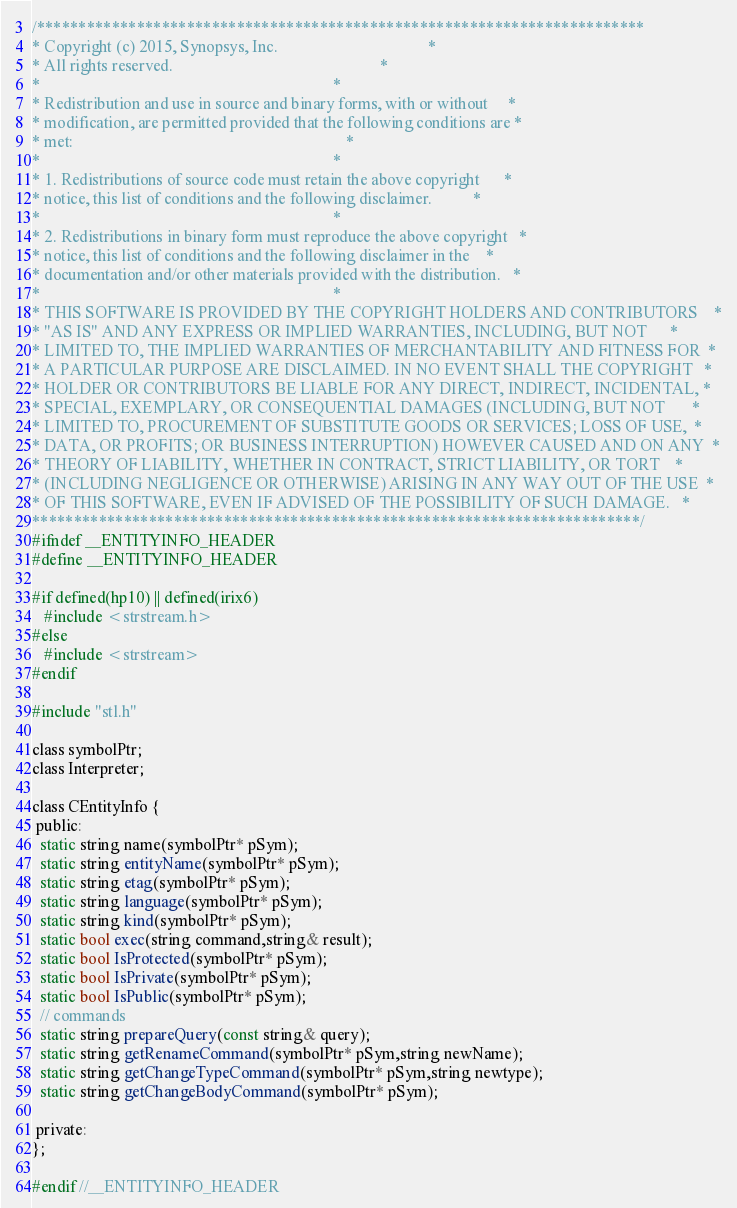Convert code to text. <code><loc_0><loc_0><loc_500><loc_500><_C_>/*************************************************************************
* Copyright (c) 2015, Synopsys, Inc.                                     *
* All rights reserved.                                                   *
*                                                                        *
* Redistribution and use in source and binary forms, with or without     *
* modification, are permitted provided that the following conditions are *
* met:                                                                   *
*                                                                        *
* 1. Redistributions of source code must retain the above copyright      *
* notice, this list of conditions and the following disclaimer.          *
*                                                                        *
* 2. Redistributions in binary form must reproduce the above copyright   *
* notice, this list of conditions and the following disclaimer in the    *
* documentation and/or other materials provided with the distribution.   *
*                                                                        *
* THIS SOFTWARE IS PROVIDED BY THE COPYRIGHT HOLDERS AND CONTRIBUTORS    *
* "AS IS" AND ANY EXPRESS OR IMPLIED WARRANTIES, INCLUDING, BUT NOT      *
* LIMITED TO, THE IMPLIED WARRANTIES OF MERCHANTABILITY AND FITNESS FOR  *
* A PARTICULAR PURPOSE ARE DISCLAIMED. IN NO EVENT SHALL THE COPYRIGHT   *
* HOLDER OR CONTRIBUTORS BE LIABLE FOR ANY DIRECT, INDIRECT, INCIDENTAL, *
* SPECIAL, EXEMPLARY, OR CONSEQUENTIAL DAMAGES (INCLUDING, BUT NOT       *
* LIMITED TO, PROCUREMENT OF SUBSTITUTE GOODS OR SERVICES; LOSS OF USE,  *
* DATA, OR PROFITS; OR BUSINESS INTERRUPTION) HOWEVER CAUSED AND ON ANY  *
* THEORY OF LIABILITY, WHETHER IN CONTRACT, STRICT LIABILITY, OR TORT    *
* (INCLUDING NEGLIGENCE OR OTHERWISE) ARISING IN ANY WAY OUT OF THE USE  *
* OF THIS SOFTWARE, EVEN IF ADVISED OF THE POSSIBILITY OF SUCH DAMAGE.   *
*************************************************************************/
#ifndef __ENTITYINFO_HEADER
#define __ENTITYINFO_HEADER

#if defined(hp10) || defined(irix6)
   #include <strstream.h>
#else
   #include <strstream>
#endif

#include "stl.h"

class symbolPtr;
class Interpreter;

class CEntityInfo {
 public:
  static string name(symbolPtr* pSym);
  static string entityName(symbolPtr* pSym);
  static string etag(symbolPtr* pSym);
  static string language(symbolPtr* pSym);
  static string kind(symbolPtr* pSym);
  static bool exec(string command,string& result);
  static bool IsProtected(symbolPtr* pSym);
  static bool IsPrivate(symbolPtr* pSym);
  static bool IsPublic(symbolPtr* pSym);
  // commands
  static string prepareQuery(const string& query);
  static string getRenameCommand(symbolPtr* pSym,string newName);
  static string getChangeTypeCommand(symbolPtr* pSym,string newtype);
  static string getChangeBodyCommand(symbolPtr* pSym);

 private:
};

#endif //__ENTITYINFO_HEADER
</code> 